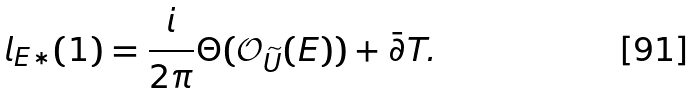<formula> <loc_0><loc_0><loc_500><loc_500>l _ { E * } ( 1 ) = \frac { i } { 2 \pi } \Theta ( \mathcal { O } _ { \widetilde { U } } ( E ) ) + \bar { \partial } T .</formula> 